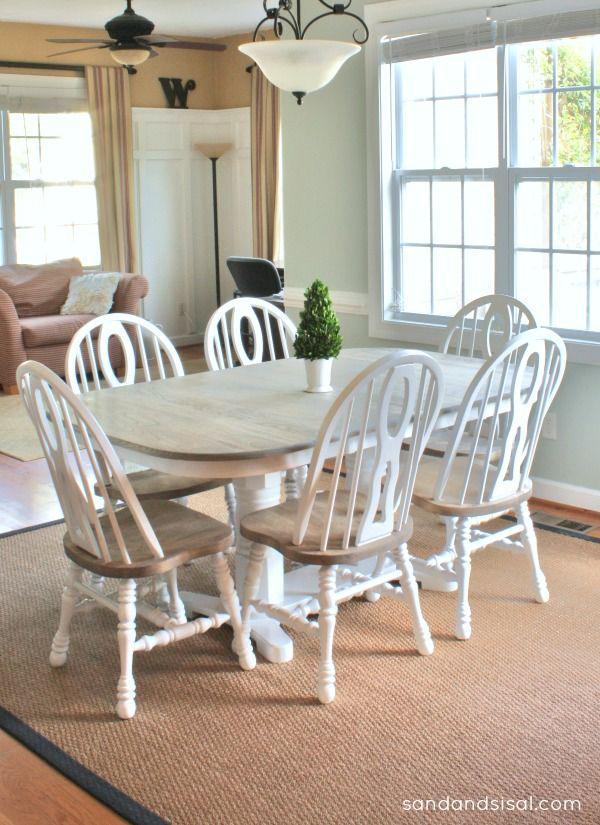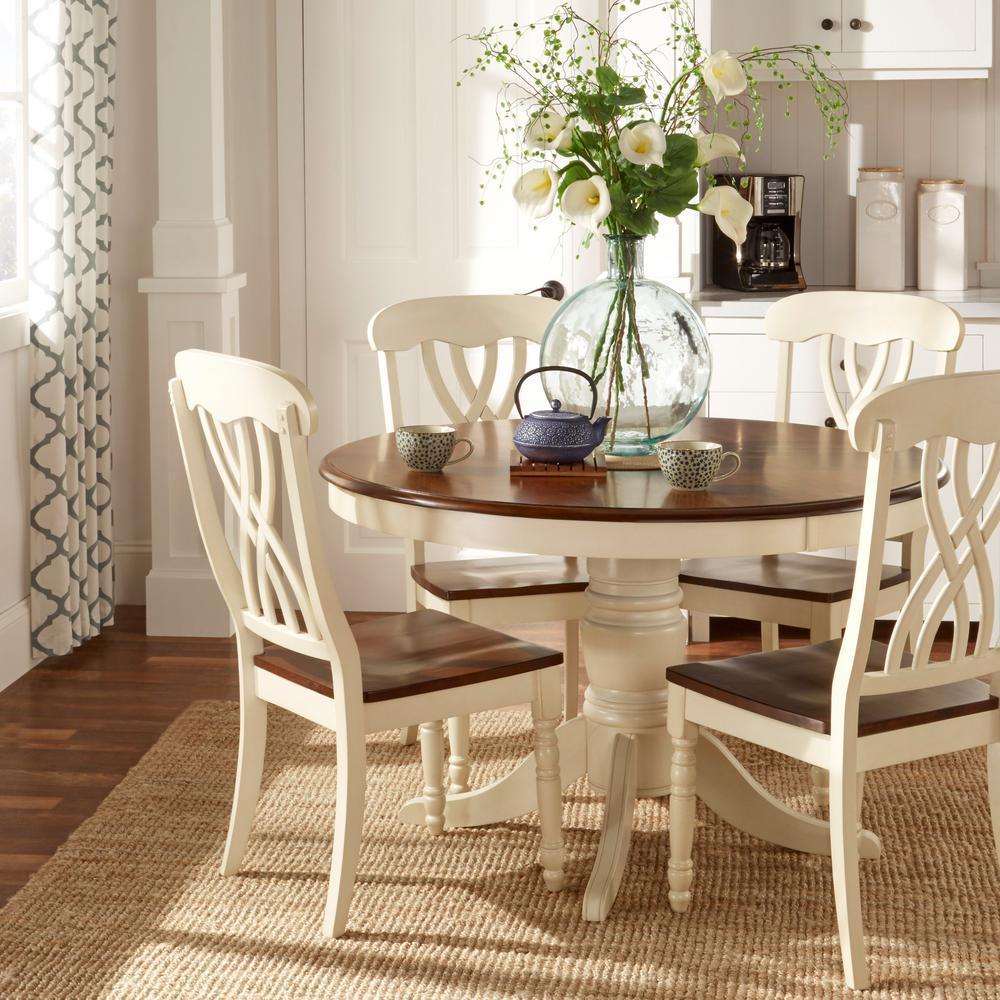The first image is the image on the left, the second image is the image on the right. For the images shown, is this caption "A dining table in one image is round with four chairs, while a table in the second image is elongated and has six chairs." true? Answer yes or no. Yes. The first image is the image on the left, the second image is the image on the right. For the images shown, is this caption "One image shows white chairs around a round pedestal table, and the other shows white chairs around an oblong pedestal table." true? Answer yes or no. Yes. 